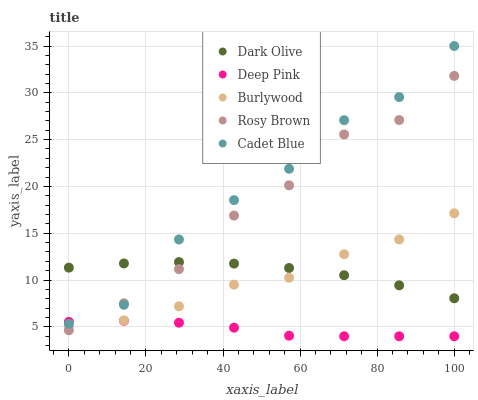Does Deep Pink have the minimum area under the curve?
Answer yes or no. Yes. Does Cadet Blue have the maximum area under the curve?
Answer yes or no. Yes. Does Rosy Brown have the minimum area under the curve?
Answer yes or no. No. Does Rosy Brown have the maximum area under the curve?
Answer yes or no. No. Is Deep Pink the smoothest?
Answer yes or no. Yes. Is Cadet Blue the roughest?
Answer yes or no. Yes. Is Rosy Brown the smoothest?
Answer yes or no. No. Is Rosy Brown the roughest?
Answer yes or no. No. Does Deep Pink have the lowest value?
Answer yes or no. Yes. Does Rosy Brown have the lowest value?
Answer yes or no. No. Does Cadet Blue have the highest value?
Answer yes or no. Yes. Does Rosy Brown have the highest value?
Answer yes or no. No. Is Burlywood less than Cadet Blue?
Answer yes or no. Yes. Is Dark Olive greater than Deep Pink?
Answer yes or no. Yes. Does Rosy Brown intersect Cadet Blue?
Answer yes or no. Yes. Is Rosy Brown less than Cadet Blue?
Answer yes or no. No. Is Rosy Brown greater than Cadet Blue?
Answer yes or no. No. Does Burlywood intersect Cadet Blue?
Answer yes or no. No. 